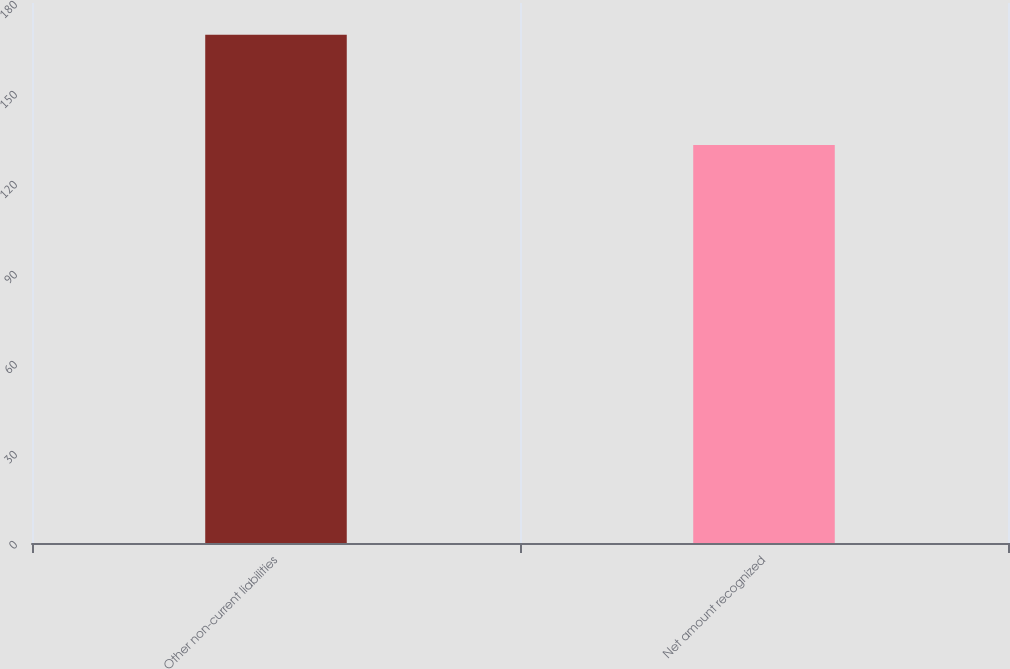Convert chart to OTSL. <chart><loc_0><loc_0><loc_500><loc_500><bar_chart><fcel>Other non-current liabilities<fcel>Net amount recognized<nl><fcel>169.4<fcel>132.7<nl></chart> 